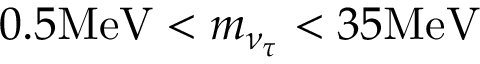<formula> <loc_0><loc_0><loc_500><loc_500>0 . 5 M e V < m _ { \nu _ { \tau } } < 3 5 M e V</formula> 